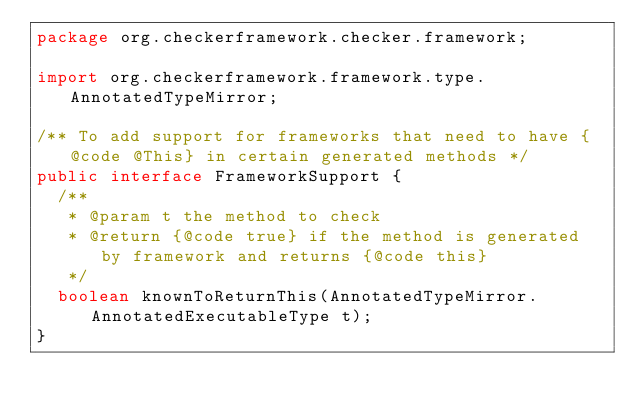Convert code to text. <code><loc_0><loc_0><loc_500><loc_500><_Java_>package org.checkerframework.checker.framework;

import org.checkerframework.framework.type.AnnotatedTypeMirror;

/** To add support for frameworks that need to have {@code @This} in certain generated methods */
public interface FrameworkSupport {
  /**
   * @param t the method to check
   * @return {@code true} if the method is generated by framework and returns {@code this}
   */
  boolean knownToReturnThis(AnnotatedTypeMirror.AnnotatedExecutableType t);
}
</code> 